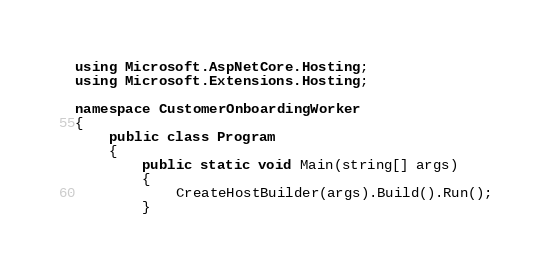<code> <loc_0><loc_0><loc_500><loc_500><_C#_>using Microsoft.AspNetCore.Hosting;
using Microsoft.Extensions.Hosting;

namespace CustomerOnboardingWorker
{
    public class Program
    {
        public static void Main(string[] args)
        {
            CreateHostBuilder(args).Build().Run();
        }
</code> 